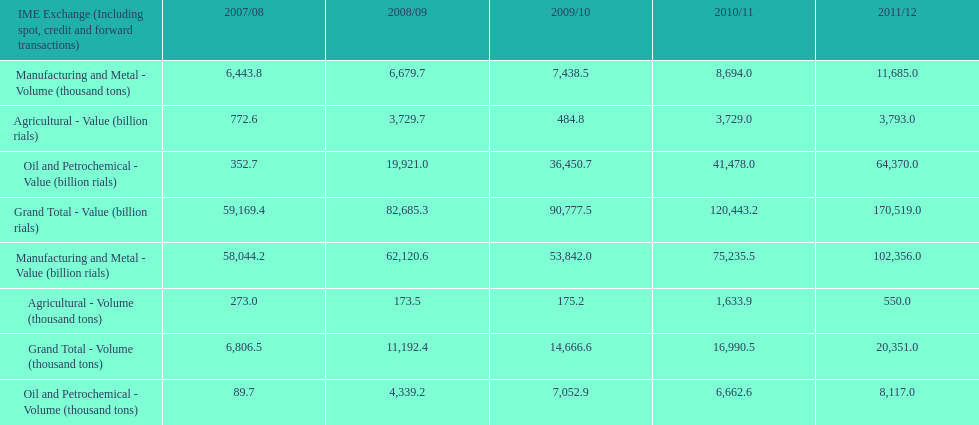What is the total agricultural value in 2008/09? 3,729.7. Can you give me this table as a dict? {'header': ['IME Exchange (Including spot, credit and forward transactions)', '2007/08', '2008/09', '2009/10', '2010/11', '2011/12'], 'rows': [['Manufacturing and Metal - Volume (thousand tons)', '6,443.8', '6,679.7', '7,438.5', '8,694.0', '11,685.0'], ['Agricultural - Value (billion rials)', '772.6', '3,729.7', '484.8', '3,729.0', '3,793.0'], ['Oil and Petrochemical - Value (billion rials)', '352.7', '19,921.0', '36,450.7', '41,478.0', '64,370.0'], ['Grand Total - Value (billion rials)', '59,169.4', '82,685.3', '90,777.5', '120,443.2', '170,519.0'], ['Manufacturing and Metal - Value (billion rials)', '58,044.2', '62,120.6', '53,842.0', '75,235.5', '102,356.0'], ['Agricultural - Volume (thousand tons)', '273.0', '173.5', '175.2', '1,633.9', '550.0'], ['Grand Total - Volume (thousand tons)', '6,806.5', '11,192.4', '14,666.6', '16,990.5', '20,351.0'], ['Oil and Petrochemical - Volume (thousand tons)', '89.7', '4,339.2', '7,052.9', '6,662.6', '8,117.0']]} 